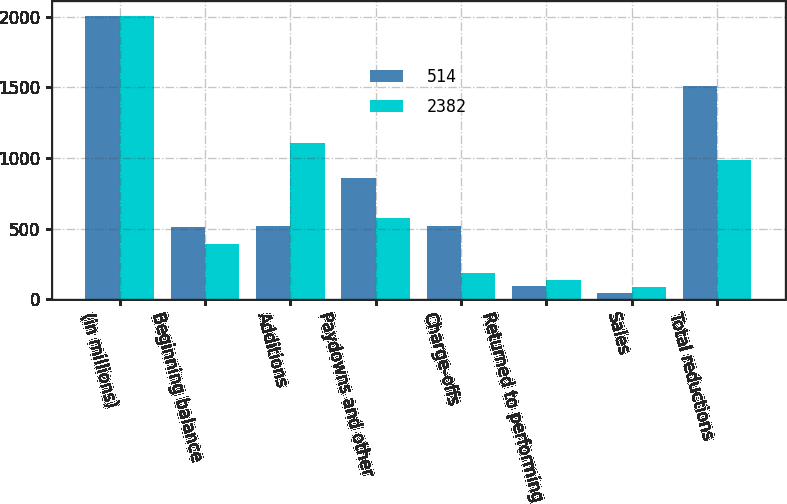Convert chart. <chart><loc_0><loc_0><loc_500><loc_500><stacked_bar_chart><ecel><fcel>(in millions)<fcel>Beginning balance<fcel>Additions<fcel>Paydowns and other<fcel>Charge-offs<fcel>Returned to performing<fcel>Sales<fcel>Total reductions<nl><fcel>514<fcel>2008<fcel>514<fcel>521<fcel>859<fcel>521<fcel>93<fcel>40<fcel>1513<nl><fcel>2382<fcel>2007<fcel>391<fcel>1107<fcel>576<fcel>185<fcel>136<fcel>87<fcel>984<nl></chart> 